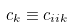<formula> <loc_0><loc_0><loc_500><loc_500>c _ { k } \equiv c _ { i i k }</formula> 